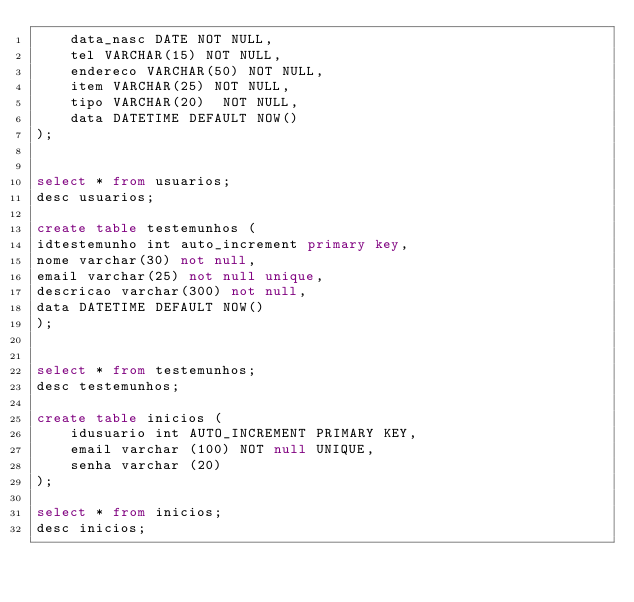Convert code to text. <code><loc_0><loc_0><loc_500><loc_500><_SQL_>    data_nasc DATE NOT NULL,
    tel VARCHAR(15) NOT NULL,
    endereco VARCHAR(50) NOT NULL,
    item VARCHAR(25) NOT NULL,
    tipo VARCHAR(20)  NOT NULL,
    data DATETIME DEFAULT NOW()
);


select * from usuarios;
desc usuarios;

create table testemunhos (
idtestemunho int auto_increment primary key,
nome varchar(30) not null,
email varchar(25) not null unique,
descricao varchar(300) not null,
data DATETIME DEFAULT NOW()
);


select * from testemunhos;
desc testemunhos;

create table inicios (    
    idusuario int AUTO_INCREMENT PRIMARY KEY,
    email varchar (100) NOT null UNIQUE,    
    senha varchar (20)
);

select * from inicios;
desc inicios;
</code> 